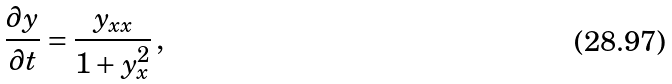Convert formula to latex. <formula><loc_0><loc_0><loc_500><loc_500>\frac { \partial y } { \partial t } = \frac { y _ { x x } } { 1 + y _ { x } ^ { 2 } } \, ,</formula> 